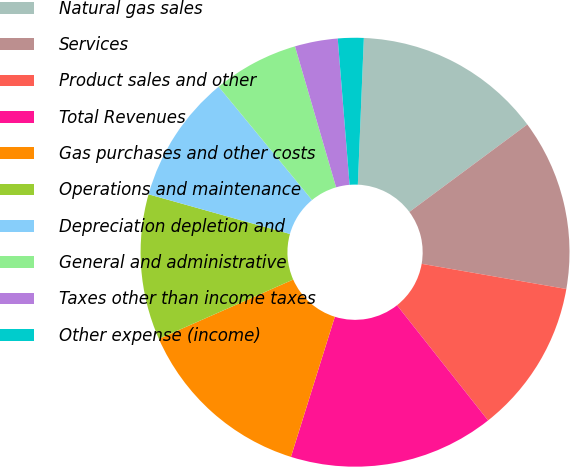<chart> <loc_0><loc_0><loc_500><loc_500><pie_chart><fcel>Natural gas sales<fcel>Services<fcel>Product sales and other<fcel>Total Revenues<fcel>Gas purchases and other costs<fcel>Operations and maintenance<fcel>Depreciation depletion and<fcel>General and administrative<fcel>Taxes other than income taxes<fcel>Other expense (income)<nl><fcel>14.19%<fcel>12.9%<fcel>11.61%<fcel>15.48%<fcel>13.55%<fcel>10.97%<fcel>9.68%<fcel>6.45%<fcel>3.23%<fcel>1.94%<nl></chart> 